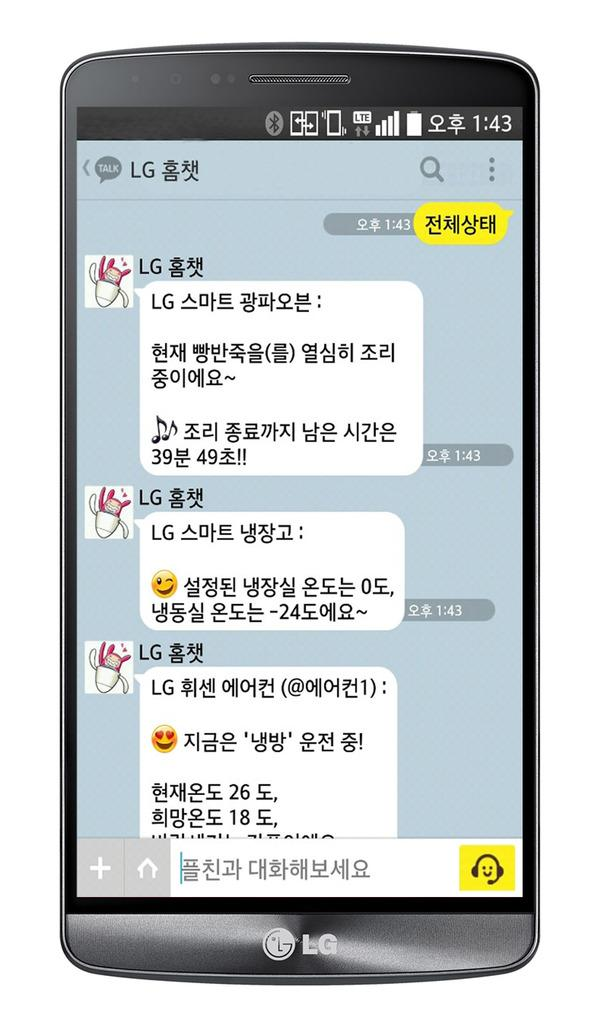<image>
Describe the image concisely. An asian text messaging thread is shown on the screen of an LG phone. 